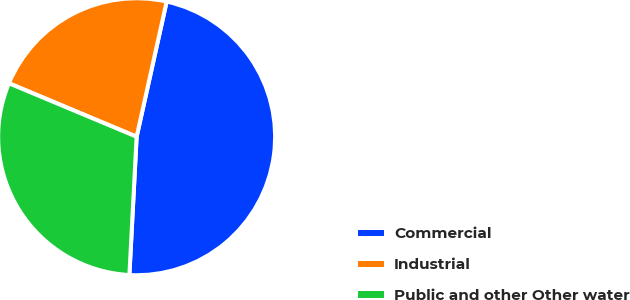Convert chart to OTSL. <chart><loc_0><loc_0><loc_500><loc_500><pie_chart><fcel>Commercial<fcel>Industrial<fcel>Public and other Other water<nl><fcel>47.36%<fcel>22.17%<fcel>30.48%<nl></chart> 